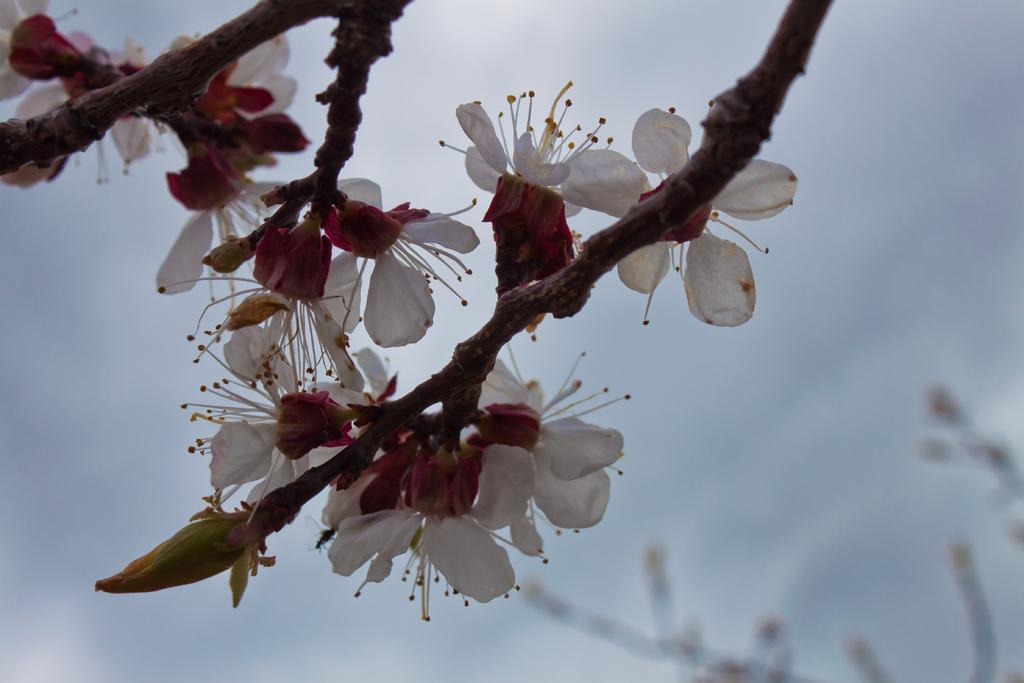What type of plants can be seen in the image? There are flowers in the image. What part of the flowers is visible in the image? There are stems in the image. What type of nerve can be seen in the image? There is no nerve present in the image; it features flowers and stems. What type of riddle is depicted in the image? There is no riddle depicted in the image; it features flowers and stems. 